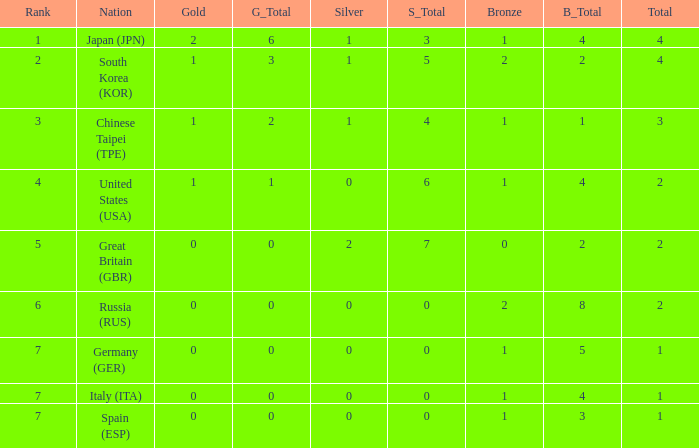What is the smallest number of gold of a country of rank 6, with 2 bronzes? None. 